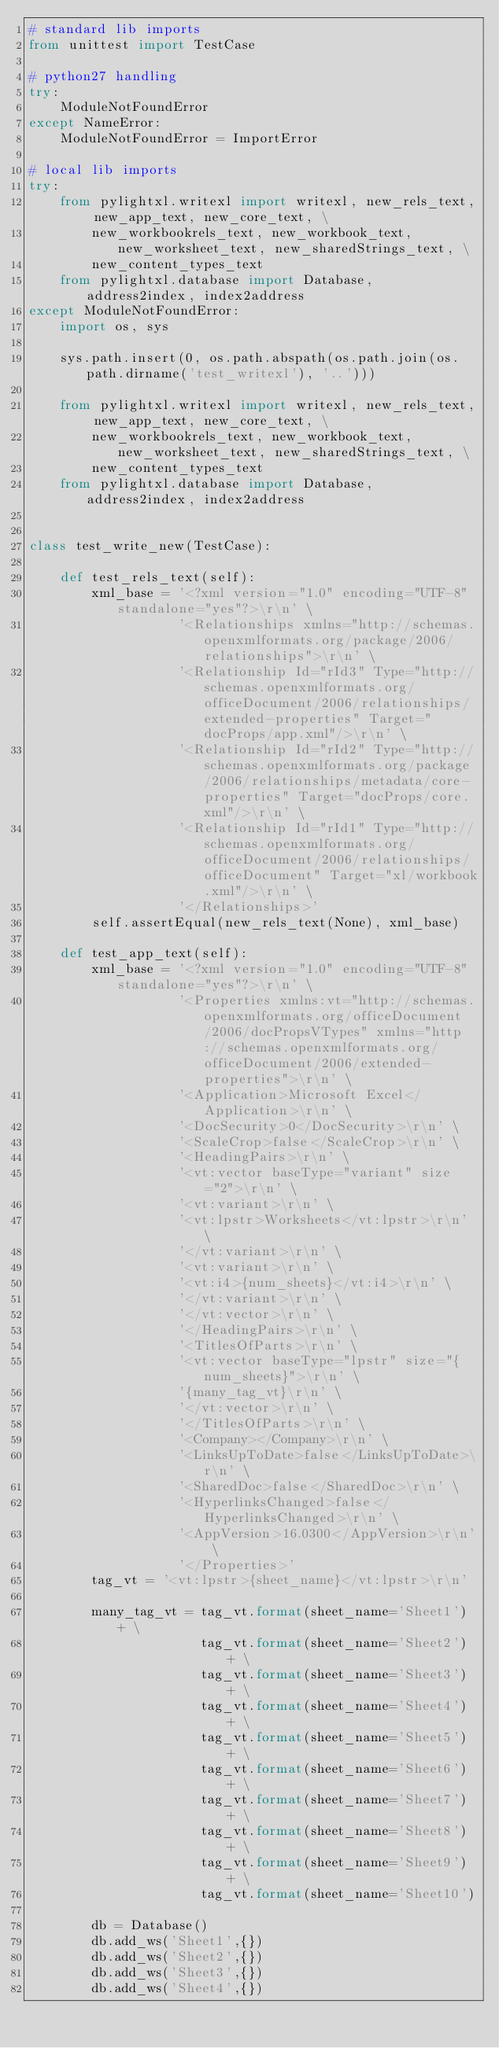Convert code to text. <code><loc_0><loc_0><loc_500><loc_500><_Python_># standard lib imports
from unittest import TestCase

# python27 handling
try:
    ModuleNotFoundError
except NameError:
    ModuleNotFoundError = ImportError

# local lib imports
try:
    from pylightxl.writexl import writexl, new_rels_text, new_app_text, new_core_text, \
        new_workbookrels_text, new_workbook_text, new_worksheet_text, new_sharedStrings_text, \
        new_content_types_text
    from pylightxl.database import Database, address2index, index2address
except ModuleNotFoundError:
    import os, sys

    sys.path.insert(0, os.path.abspath(os.path.join(os.path.dirname('test_writexl'), '..')))

    from pylightxl.writexl import writexl, new_rels_text, new_app_text, new_core_text, \
        new_workbookrels_text, new_workbook_text, new_worksheet_text, new_sharedStrings_text, \
        new_content_types_text
    from pylightxl.database import Database, address2index, index2address


class test_write_new(TestCase):

    def test_rels_text(self):
        xml_base = '<?xml version="1.0" encoding="UTF-8" standalone="yes"?>\r\n' \
                   '<Relationships xmlns="http://schemas.openxmlformats.org/package/2006/relationships">\r\n' \
                   '<Relationship Id="rId3" Type="http://schemas.openxmlformats.org/officeDocument/2006/relationships/extended-properties" Target="docProps/app.xml"/>\r\n' \
                   '<Relationship Id="rId2" Type="http://schemas.openxmlformats.org/package/2006/relationships/metadata/core-properties" Target="docProps/core.xml"/>\r\n' \
                   '<Relationship Id="rId1" Type="http://schemas.openxmlformats.org/officeDocument/2006/relationships/officeDocument" Target="xl/workbook.xml"/>\r\n' \
                   '</Relationships>'
        self.assertEqual(new_rels_text(None), xml_base)

    def test_app_text(self):
        xml_base = '<?xml version="1.0" encoding="UTF-8" standalone="yes"?>\r\n' \
                   '<Properties xmlns:vt="http://schemas.openxmlformats.org/officeDocument/2006/docPropsVTypes" xmlns="http://schemas.openxmlformats.org/officeDocument/2006/extended-properties">\r\n' \
                   '<Application>Microsoft Excel</Application>\r\n' \
                   '<DocSecurity>0</DocSecurity>\r\n' \
                   '<ScaleCrop>false</ScaleCrop>\r\n' \
                   '<HeadingPairs>\r\n' \
                   '<vt:vector baseType="variant" size="2">\r\n' \
                   '<vt:variant>\r\n' \
                   '<vt:lpstr>Worksheets</vt:lpstr>\r\n' \
                   '</vt:variant>\r\n' \
                   '<vt:variant>\r\n' \
                   '<vt:i4>{num_sheets}</vt:i4>\r\n' \
                   '</vt:variant>\r\n' \
                   '</vt:vector>\r\n' \
                   '</HeadingPairs>\r\n' \
                   '<TitlesOfParts>\r\n' \
                   '<vt:vector baseType="lpstr" size="{num_sheets}">\r\n' \
                   '{many_tag_vt}\r\n' \
                   '</vt:vector>\r\n' \
                   '</TitlesOfParts>\r\n' \
                   '<Company></Company>\r\n' \
                   '<LinksUpToDate>false</LinksUpToDate>\r\n' \
                   '<SharedDoc>false</SharedDoc>\r\n' \
                   '<HyperlinksChanged>false</HyperlinksChanged>\r\n' \
                   '<AppVersion>16.0300</AppVersion>\r\n' \
                   '</Properties>'
        tag_vt = '<vt:lpstr>{sheet_name}</vt:lpstr>\r\n'

        many_tag_vt = tag_vt.format(sheet_name='Sheet1') + \
                      tag_vt.format(sheet_name='Sheet2') + \
                      tag_vt.format(sheet_name='Sheet3') + \
                      tag_vt.format(sheet_name='Sheet4') + \
                      tag_vt.format(sheet_name='Sheet5') + \
                      tag_vt.format(sheet_name='Sheet6') + \
                      tag_vt.format(sheet_name='Sheet7') + \
                      tag_vt.format(sheet_name='Sheet8') + \
                      tag_vt.format(sheet_name='Sheet9') + \
                      tag_vt.format(sheet_name='Sheet10')

        db = Database()
        db.add_ws('Sheet1',{})
        db.add_ws('Sheet2',{})
        db.add_ws('Sheet3',{})
        db.add_ws('Sheet4',{})</code> 